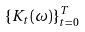<formula> <loc_0><loc_0><loc_500><loc_500>\{ K _ { t } ( \omega ) \} _ { t = 0 } ^ { T }</formula> 